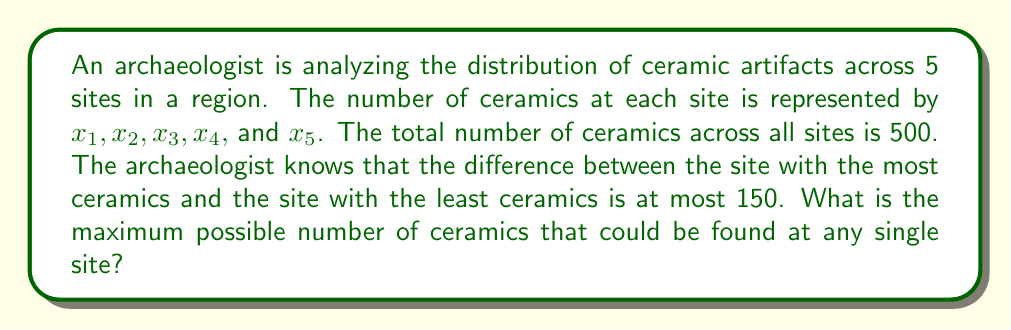Provide a solution to this math problem. Let's approach this step-by-step:

1) Let $x_{max}$ be the maximum number of ceramics at any site and $x_{min}$ be the minimum.

2) We're given that:
   $$x_1 + x_2 + x_3 + x_4 + x_5 = 500$$
   $$x_{max} - x_{min} \leq 150$$

3) To maximize $x_{max}$, we need to minimize the other values. The smallest possible value for $x_{min}$ is:
   $$x_{min} = x_{max} - 150$$

4) The remaining three sites should also have this minimum value to maximize $x_{max}$. So we can write:
   $$x_{max} + (x_{max} - 150) + 3(x_{max} - 150) = 500$$

5) Simplifying:
   $$5x_{max} - 600 = 500$$
   $$5x_{max} = 1100$$
   $$x_{max} = 220$$

6) We can verify that this satisfies our conditions:
   - The maximum (220) minus the minimum (70) is 150
   - The sum of all sites (220 + 70 + 70 + 70 + 70 = 500) matches the total

Therefore, the maximum possible number of ceramics at any single site is 220.
Answer: 220 